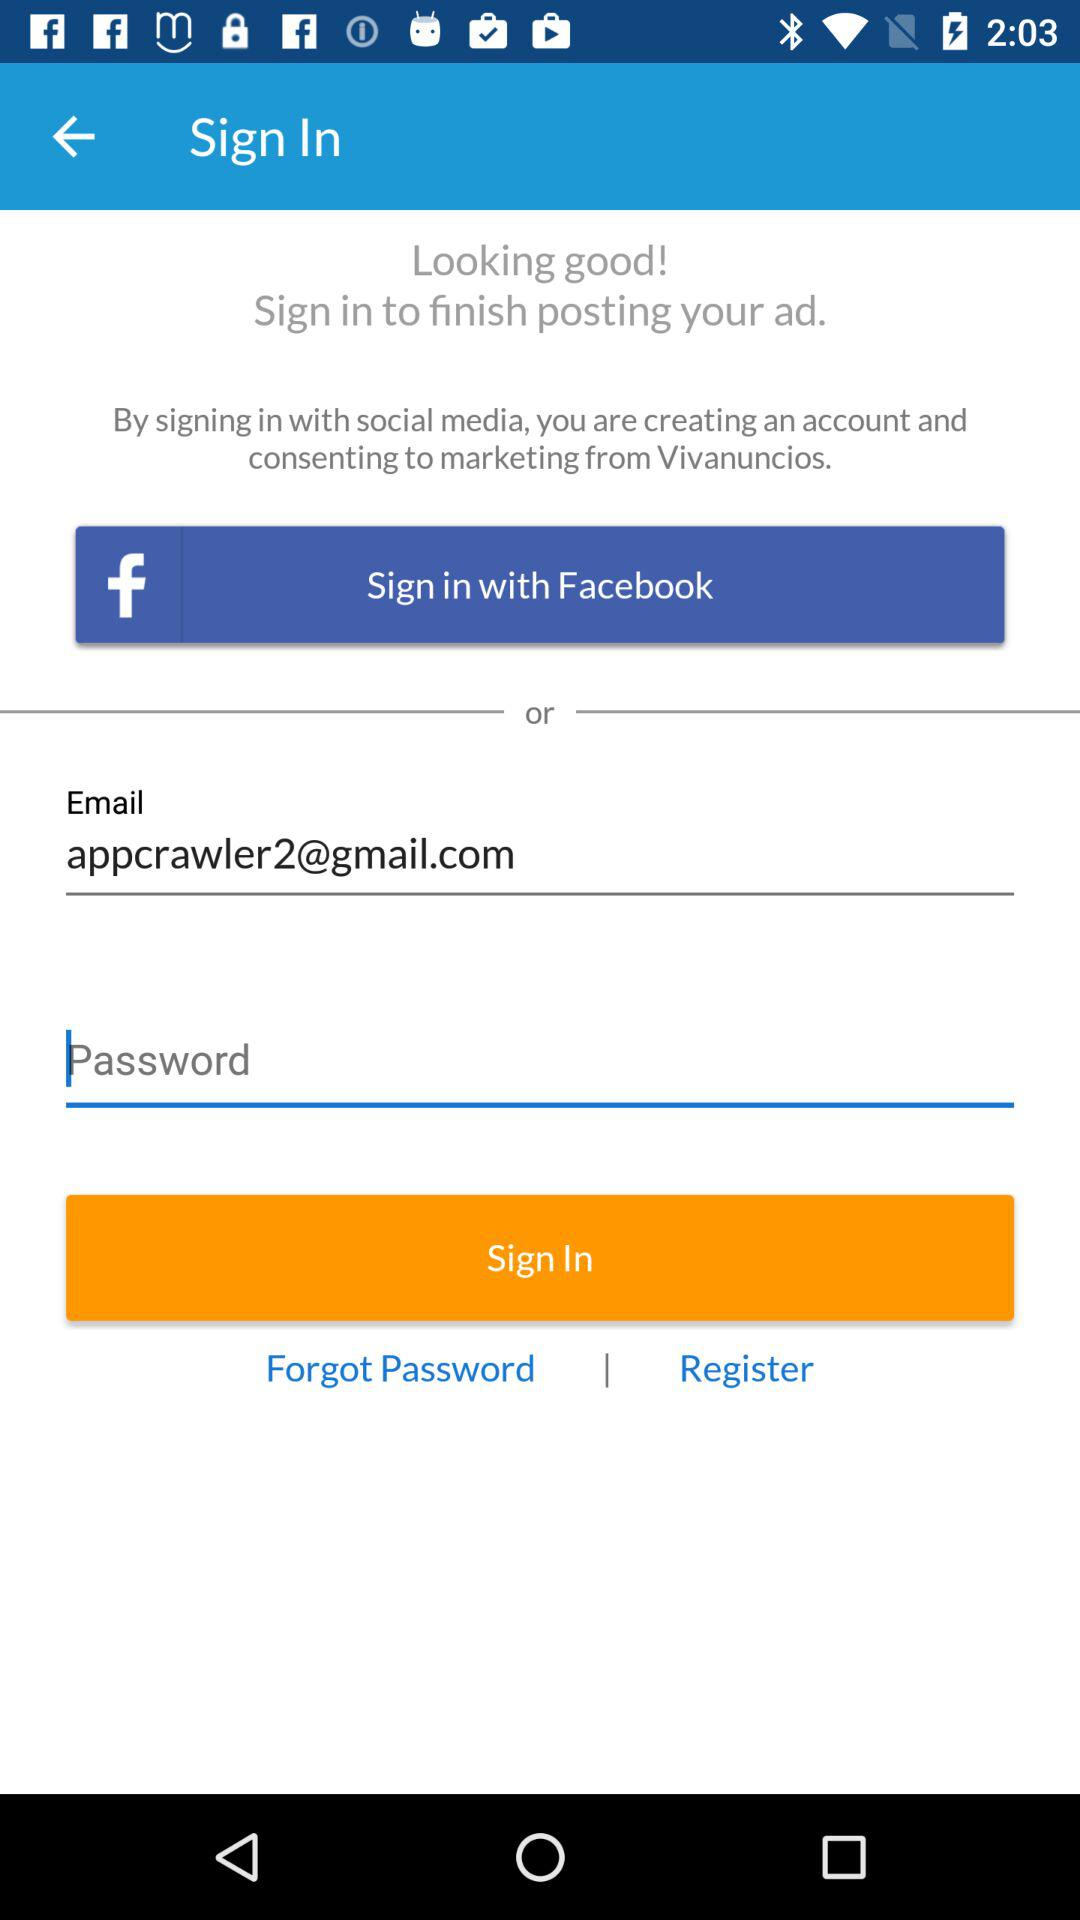What is the given email address? The given email address is appcrawler2@gmail.com. 